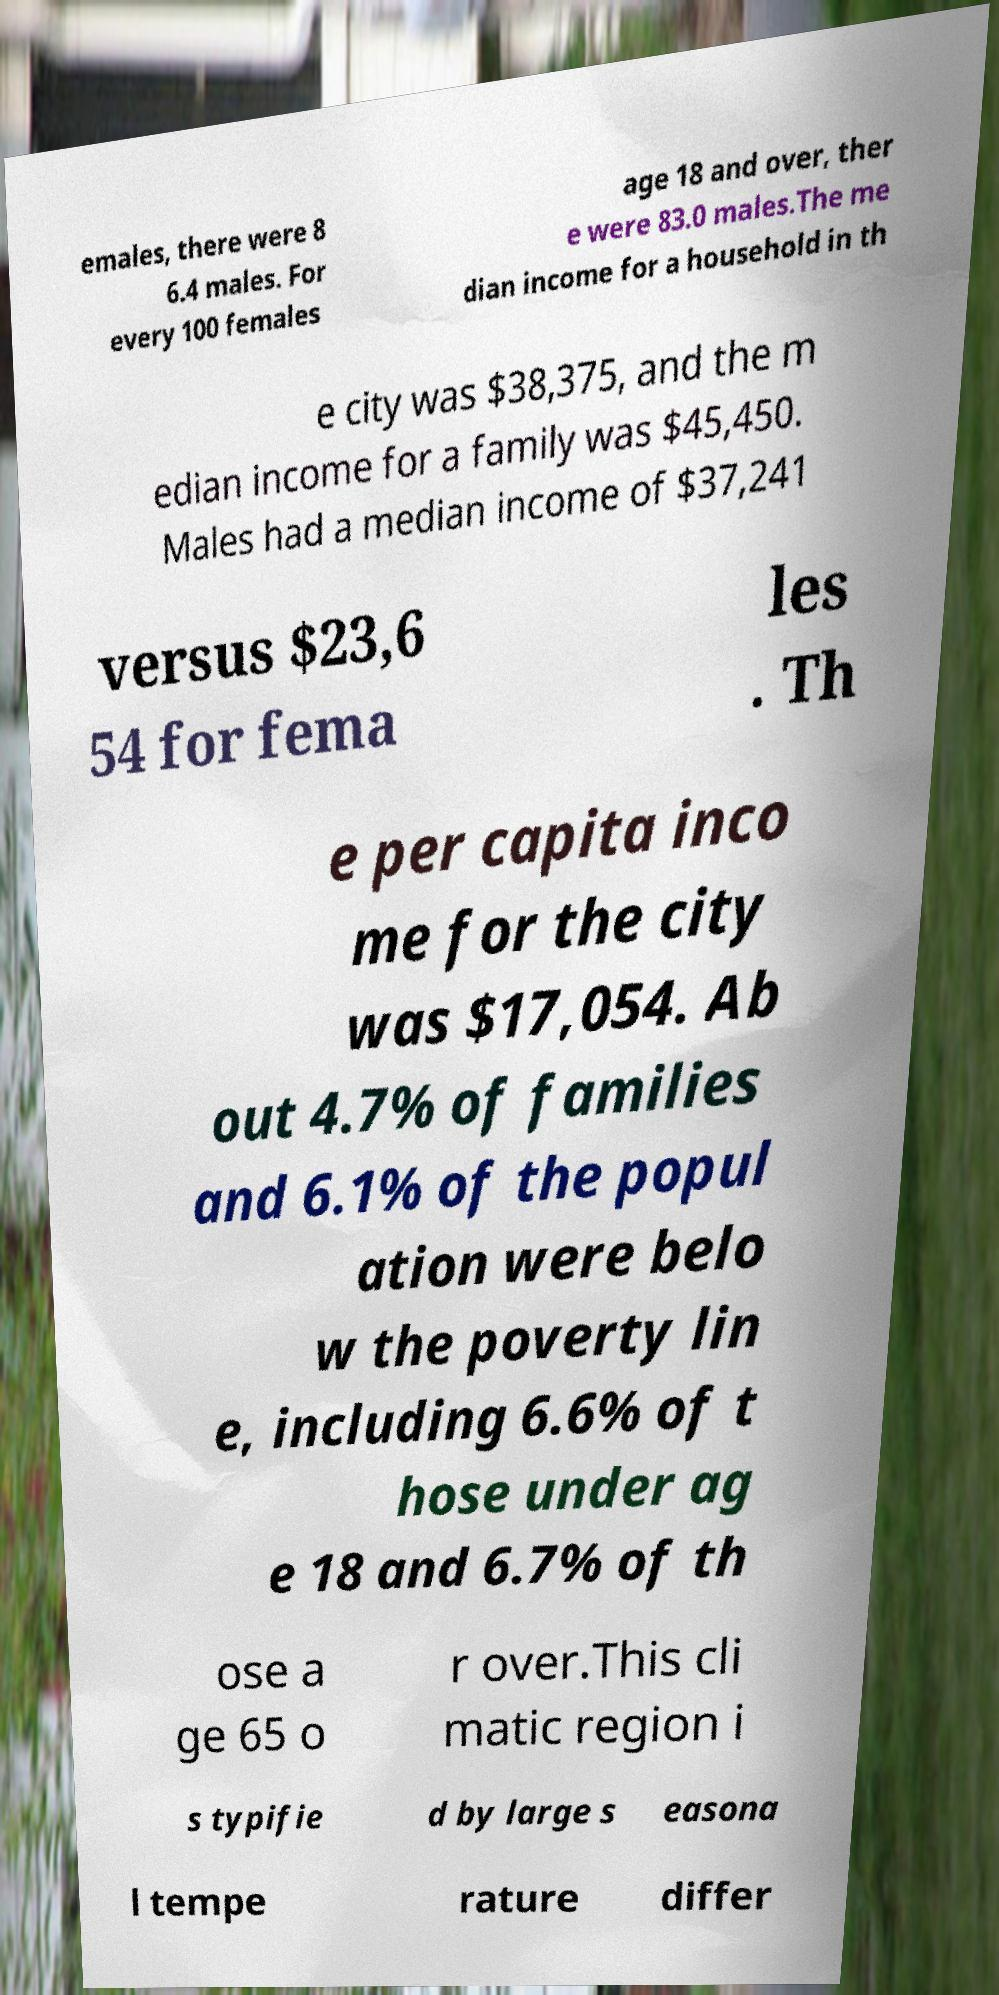For documentation purposes, I need the text within this image transcribed. Could you provide that? emales, there were 8 6.4 males. For every 100 females age 18 and over, ther e were 83.0 males.The me dian income for a household in th e city was $38,375, and the m edian income for a family was $45,450. Males had a median income of $37,241 versus $23,6 54 for fema les . Th e per capita inco me for the city was $17,054. Ab out 4.7% of families and 6.1% of the popul ation were belo w the poverty lin e, including 6.6% of t hose under ag e 18 and 6.7% of th ose a ge 65 o r over.This cli matic region i s typifie d by large s easona l tempe rature differ 